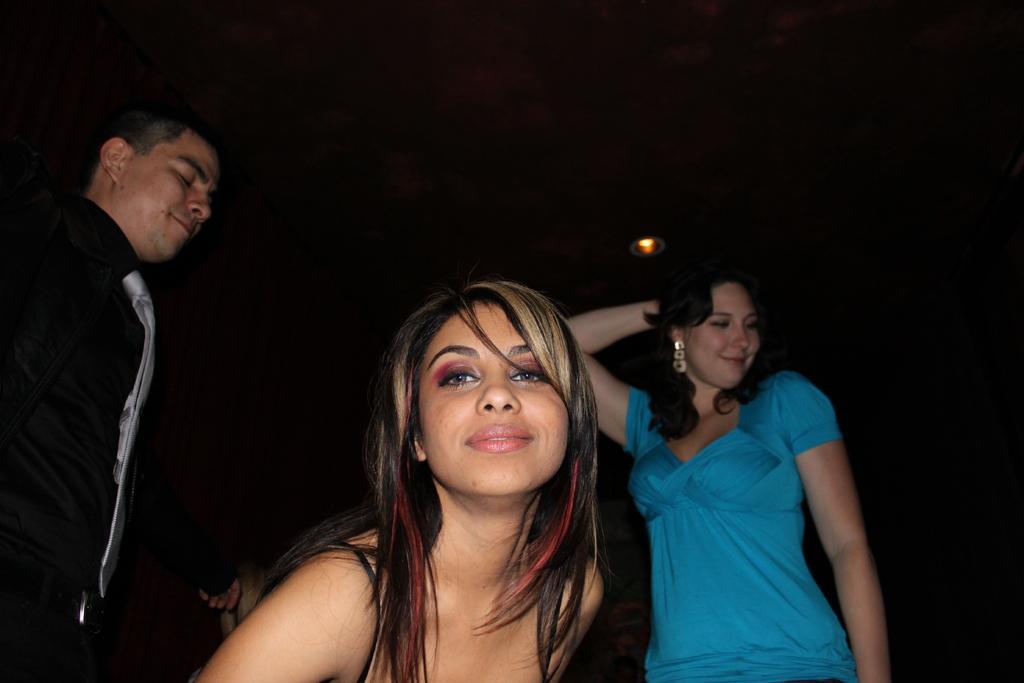Please provide a concise description of this image. In this image I can see three people with different color dresses and I can see the black background and light. 